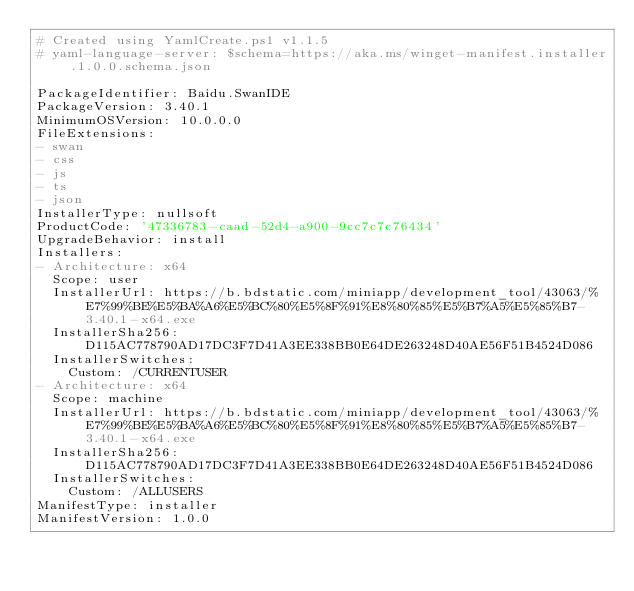Convert code to text. <code><loc_0><loc_0><loc_500><loc_500><_YAML_># Created using YamlCreate.ps1 v1.1.5
# yaml-language-server: $schema=https://aka.ms/winget-manifest.installer.1.0.0.schema.json

PackageIdentifier: Baidu.SwanIDE
PackageVersion: 3.40.1
MinimumOSVersion: 10.0.0.0
FileExtensions:
- swan
- css
- js
- ts
- json
InstallerType: nullsoft
ProductCode: '47336783-caad-52d4-a900-9cc7c7c76434'
UpgradeBehavior: install
Installers:
- Architecture: x64
  Scope: user
  InstallerUrl: https://b.bdstatic.com/miniapp/development_tool/43063/%E7%99%BE%E5%BA%A6%E5%BC%80%E5%8F%91%E8%80%85%E5%B7%A5%E5%85%B7-3.40.1-x64.exe
  InstallerSha256: D115AC778790AD17DC3F7D41A3EE338BB0E64DE263248D40AE56F51B4524D086
  InstallerSwitches:
    Custom: /CURRENTUSER
- Architecture: x64
  Scope: machine
  InstallerUrl: https://b.bdstatic.com/miniapp/development_tool/43063/%E7%99%BE%E5%BA%A6%E5%BC%80%E5%8F%91%E8%80%85%E5%B7%A5%E5%85%B7-3.40.1-x64.exe
  InstallerSha256: D115AC778790AD17DC3F7D41A3EE338BB0E64DE263248D40AE56F51B4524D086
  InstallerSwitches:
    Custom: /ALLUSERS
ManifestType: installer
ManifestVersion: 1.0.0

</code> 